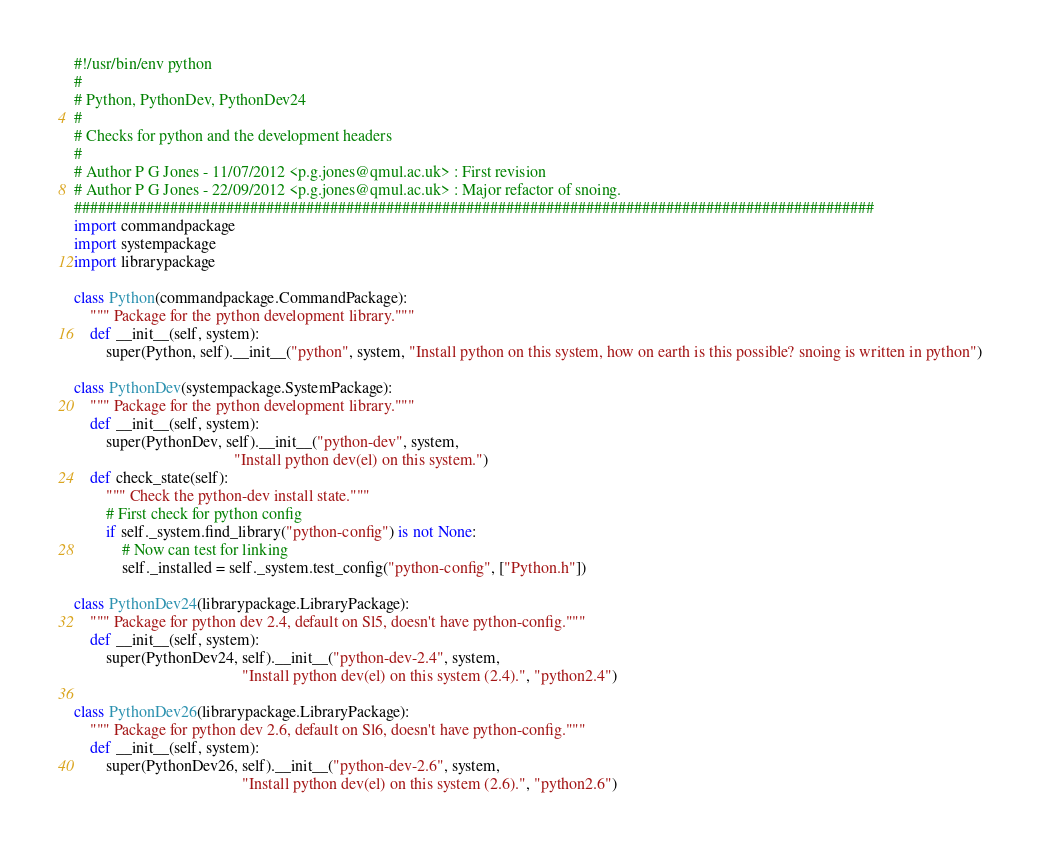Convert code to text. <code><loc_0><loc_0><loc_500><loc_500><_Python_>#!/usr/bin/env python
#
# Python, PythonDev, PythonDev24
#
# Checks for python and the development headers
#
# Author P G Jones - 11/07/2012 <p.g.jones@qmul.ac.uk> : First revision
# Author P G Jones - 22/09/2012 <p.g.jones@qmul.ac.uk> : Major refactor of snoing.
####################################################################################################
import commandpackage
import systempackage
import librarypackage

class Python(commandpackage.CommandPackage):
    """ Package for the python development library."""
    def __init__(self, system):
        super(Python, self).__init__("python", system, "Install python on this system, how on earth is this possible? snoing is written in python")

class PythonDev(systempackage.SystemPackage):
    """ Package for the python development library."""
    def __init__(self, system):
        super(PythonDev, self).__init__("python-dev", system, 
                                        "Install python dev(el) on this system.")
    def check_state(self):
        """ Check the python-dev install state."""
        # First check for python config
        if self._system.find_library("python-config") is not None:
            # Now can test for linking
            self._installed = self._system.test_config("python-config", ["Python.h"])

class PythonDev24(librarypackage.LibraryPackage):
    """ Package for python dev 2.4, default on Sl5, doesn't have python-config."""
    def __init__(self, system):
        super(PythonDev24, self).__init__("python-dev-2.4", system, 
                                          "Install python dev(el) on this system (2.4).", "python2.4")

class PythonDev26(librarypackage.LibraryPackage):
    """ Package for python dev 2.6, default on Sl6, doesn't have python-config."""
    def __init__(self, system):
        super(PythonDev26, self).__init__("python-dev-2.6", system, 
                                          "Install python dev(el) on this system (2.6).", "python2.6")
</code> 